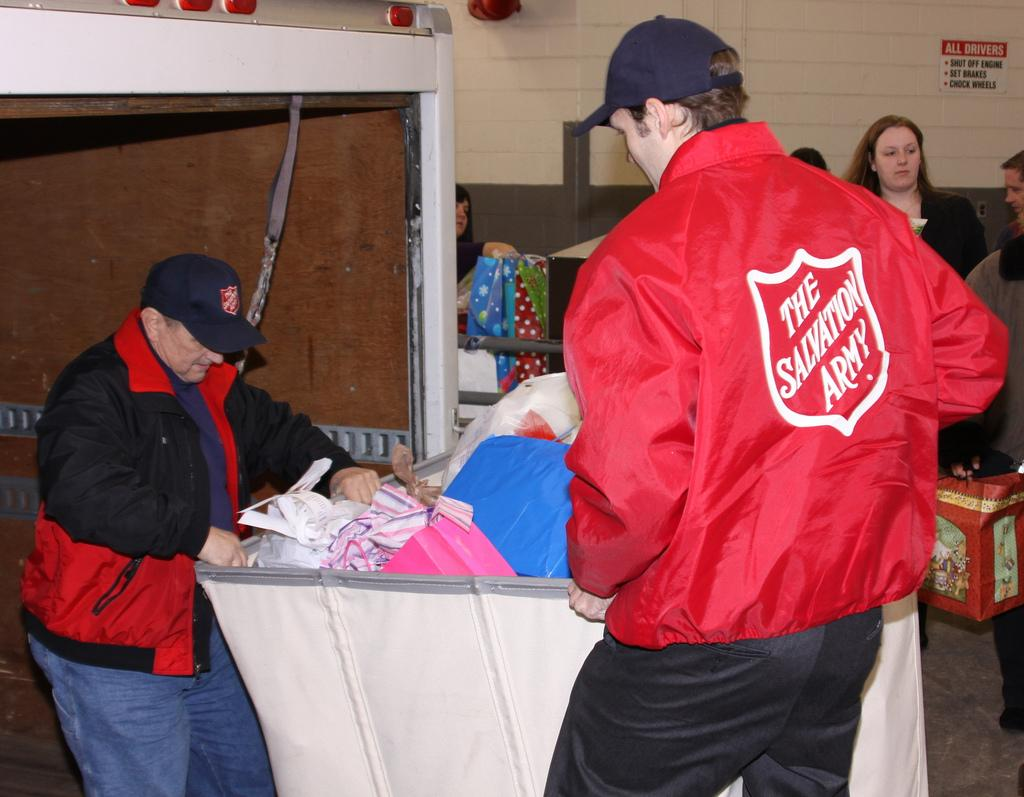<image>
Create a compact narrative representing the image presented. Workers at the Salvation Army are carrying a bin full of donations. 